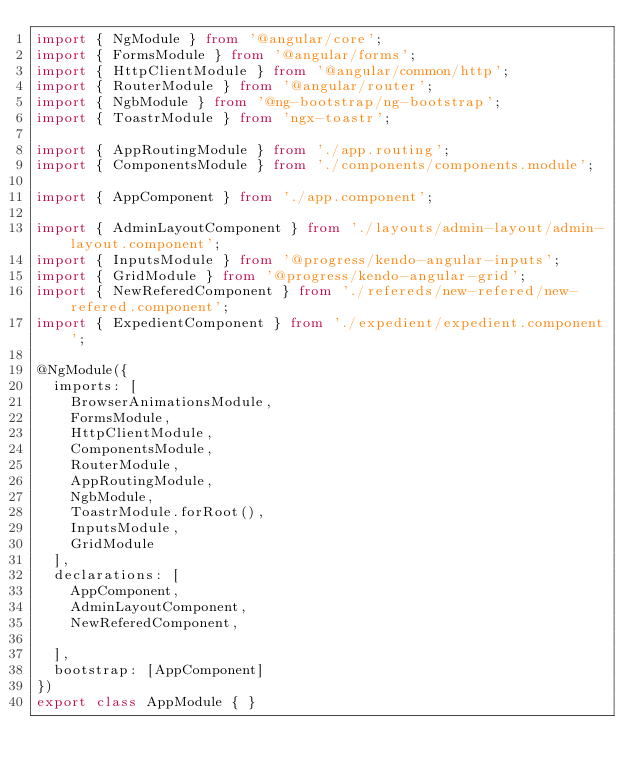Convert code to text. <code><loc_0><loc_0><loc_500><loc_500><_TypeScript_>import { NgModule } from '@angular/core';
import { FormsModule } from '@angular/forms';
import { HttpClientModule } from '@angular/common/http';
import { RouterModule } from '@angular/router';
import { NgbModule } from '@ng-bootstrap/ng-bootstrap';
import { ToastrModule } from 'ngx-toastr';

import { AppRoutingModule } from './app.routing';
import { ComponentsModule } from './components/components.module';

import { AppComponent } from './app.component';

import { AdminLayoutComponent } from './layouts/admin-layout/admin-layout.component';
import { InputsModule } from '@progress/kendo-angular-inputs';
import { GridModule } from '@progress/kendo-angular-grid';
import { NewReferedComponent } from './refereds/new-refered/new-refered.component';
import { ExpedientComponent } from './expedient/expedient.component';

@NgModule({
  imports: [
    BrowserAnimationsModule,
    FormsModule,
    HttpClientModule,
    ComponentsModule,
    RouterModule,
    AppRoutingModule,
    NgbModule,
    ToastrModule.forRoot(),
    InputsModule,
    GridModule
  ],
  declarations: [
    AppComponent,
    AdminLayoutComponent,
    NewReferedComponent,
    
  ],
  bootstrap: [AppComponent]
})
export class AppModule { }
</code> 